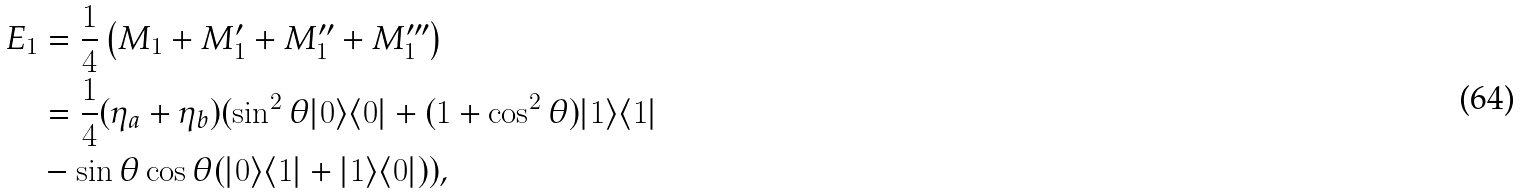<formula> <loc_0><loc_0><loc_500><loc_500>E _ { 1 } & = \frac { 1 } { 4 } \left ( M _ { 1 } + M ^ { \prime } _ { 1 } + M ^ { \prime \prime } _ { 1 } + M ^ { \prime \prime \prime } _ { 1 } \right ) \\ & = \frac { 1 } { 4 } ( \eta _ { a } + \eta _ { b } ) ( \sin ^ { 2 } \theta | 0 \rangle \langle 0 | + ( 1 + \cos ^ { 2 } \theta ) | 1 \rangle \langle 1 | \\ & - \sin \theta \cos \theta ( | 0 \rangle \langle 1 | + | 1 \rangle \langle 0 | ) ) \text {,}</formula> 